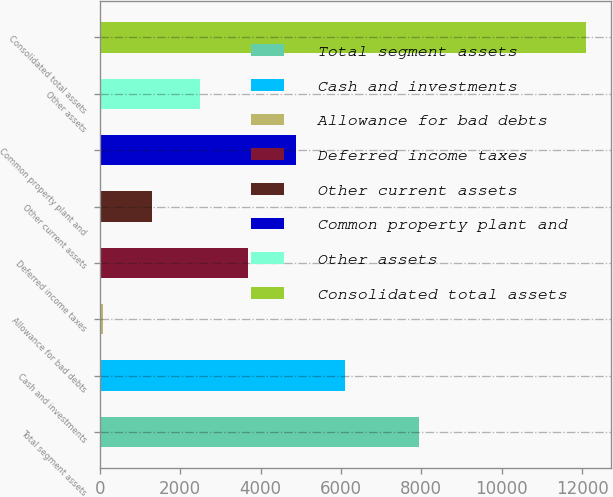Convert chart to OTSL. <chart><loc_0><loc_0><loc_500><loc_500><bar_chart><fcel>Total segment assets<fcel>Cash and investments<fcel>Allowance for bad debts<fcel>Deferred income taxes<fcel>Other current assets<fcel>Common property plant and<fcel>Other assets<fcel>Consolidated total assets<nl><fcel>7932<fcel>6094.5<fcel>87<fcel>3691.5<fcel>1288.5<fcel>4893<fcel>2490<fcel>12102<nl></chart> 